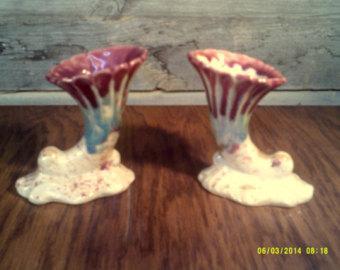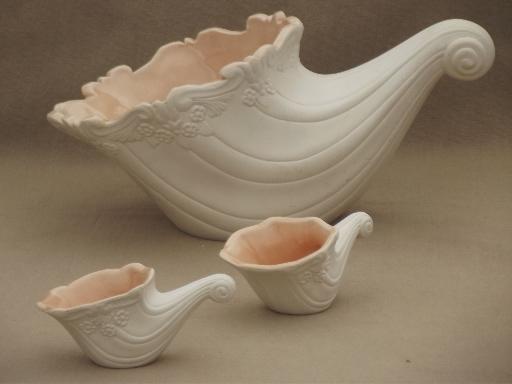The first image is the image on the left, the second image is the image on the right. For the images shown, is this caption "Each image contains at least two vases shaped like ocean waves, and the left image shows the waves facing each other, while the right image shows them aimed leftward." true? Answer yes or no. Yes. The first image is the image on the left, the second image is the image on the right. For the images shown, is this caption "Each image contains a pair of matching objects." true? Answer yes or no. Yes. 